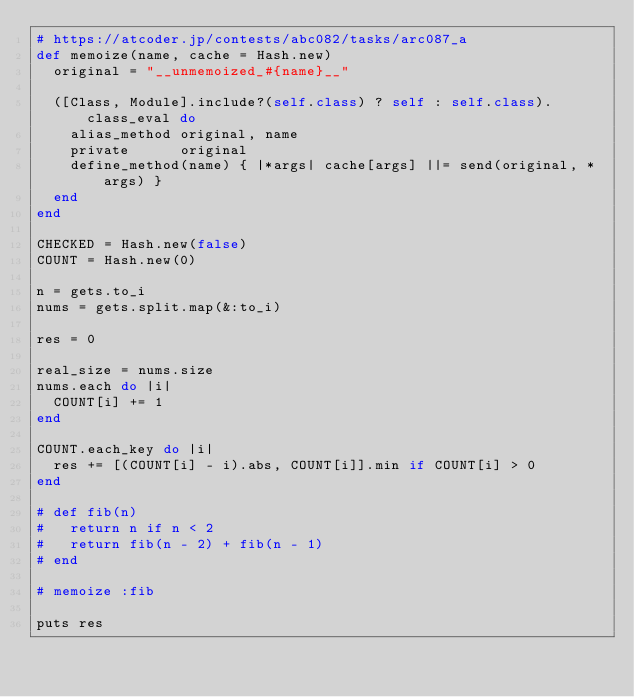Convert code to text. <code><loc_0><loc_0><loc_500><loc_500><_Ruby_># https://atcoder.jp/contests/abc082/tasks/arc087_a
def memoize(name, cache = Hash.new)
  original = "__unmemoized_#{name}__"
  
  ([Class, Module].include?(self.class) ? self : self.class).class_eval do
    alias_method original, name
    private      original
    define_method(name) { |*args| cache[args] ||= send(original, *args) }
  end 
end 

CHECKED = Hash.new(false)
COUNT = Hash.new(0)

n = gets.to_i
nums = gets.split.map(&:to_i)

res = 0

real_size = nums.size
nums.each do |i|
  COUNT[i] += 1
end

COUNT.each_key do |i|
  res += [(COUNT[i] - i).abs, COUNT[i]].min if COUNT[i] > 0
end

# def fib(n)
#   return n if n < 2
#   return fib(n - 2) + fib(n - 1)
# end

# memoize :fib

puts res</code> 